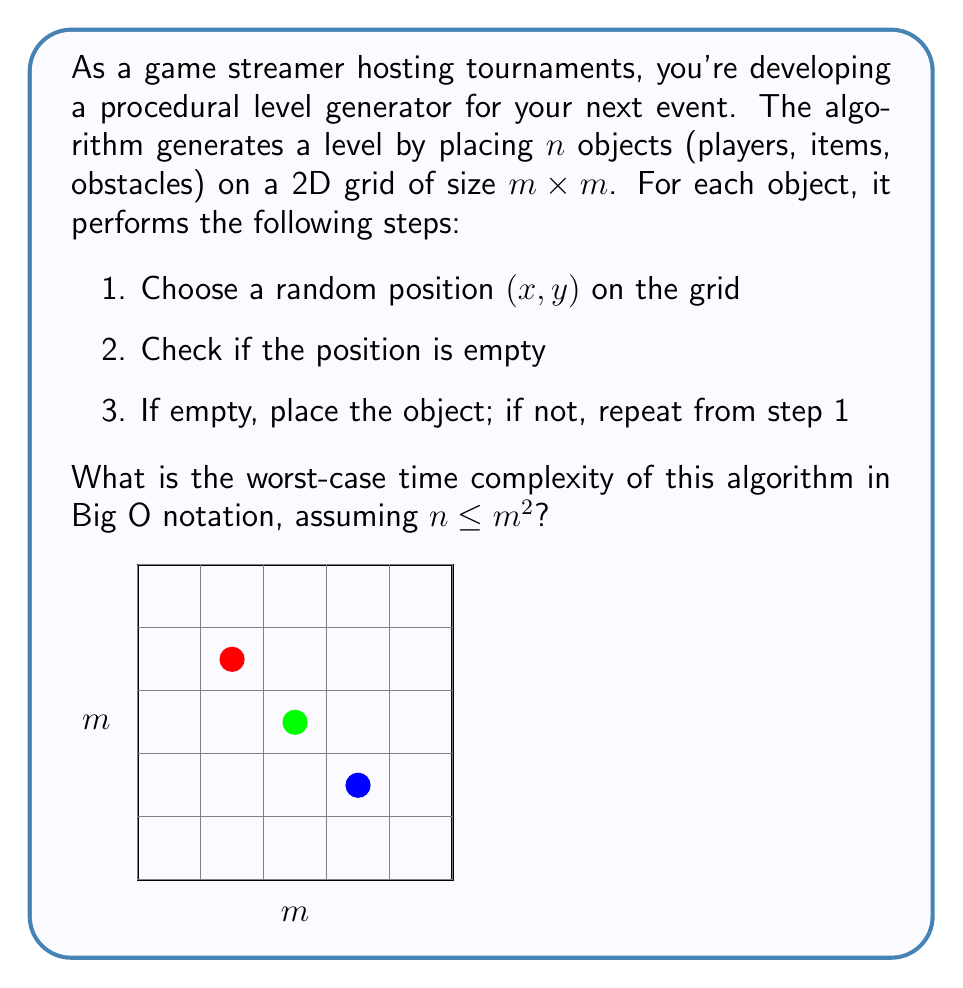Can you answer this question? Let's analyze the algorithm step-by-step:

1) The outer loop runs $n$ times, once for each object to be placed.

2) In each iteration:
   a) Generating a random position takes $O(1)$ time.
   b) Checking if a position is empty also takes $O(1)$ time.
   c) The worst case occurs when all but one cell are filled, and we keep generating occupied positions.

3) In the worst case, for the last object, we might need to try all $m^2$ positions before finding the empty one.

4) This gives us a series: $1 + 1 + 1 + ... + m^2$ (with $n$ terms)

5) We can upper bound this by $n \cdot m^2$, as each of the $n$ objects might take up to $m^2$ tries in the worst case.

6) Given that $n \leq m^2$, we can substitute $n$ with $m^2$:
   $m^2 \cdot m^2 = m^4$

7) Therefore, the worst-case time complexity is $O(m^4)$.

It's worth noting that this is a very pessimistic upper bound. In practice, the average-case performance would be much better, especially if $n$ is significantly smaller than $m^2$.
Answer: $O(m^4)$ 